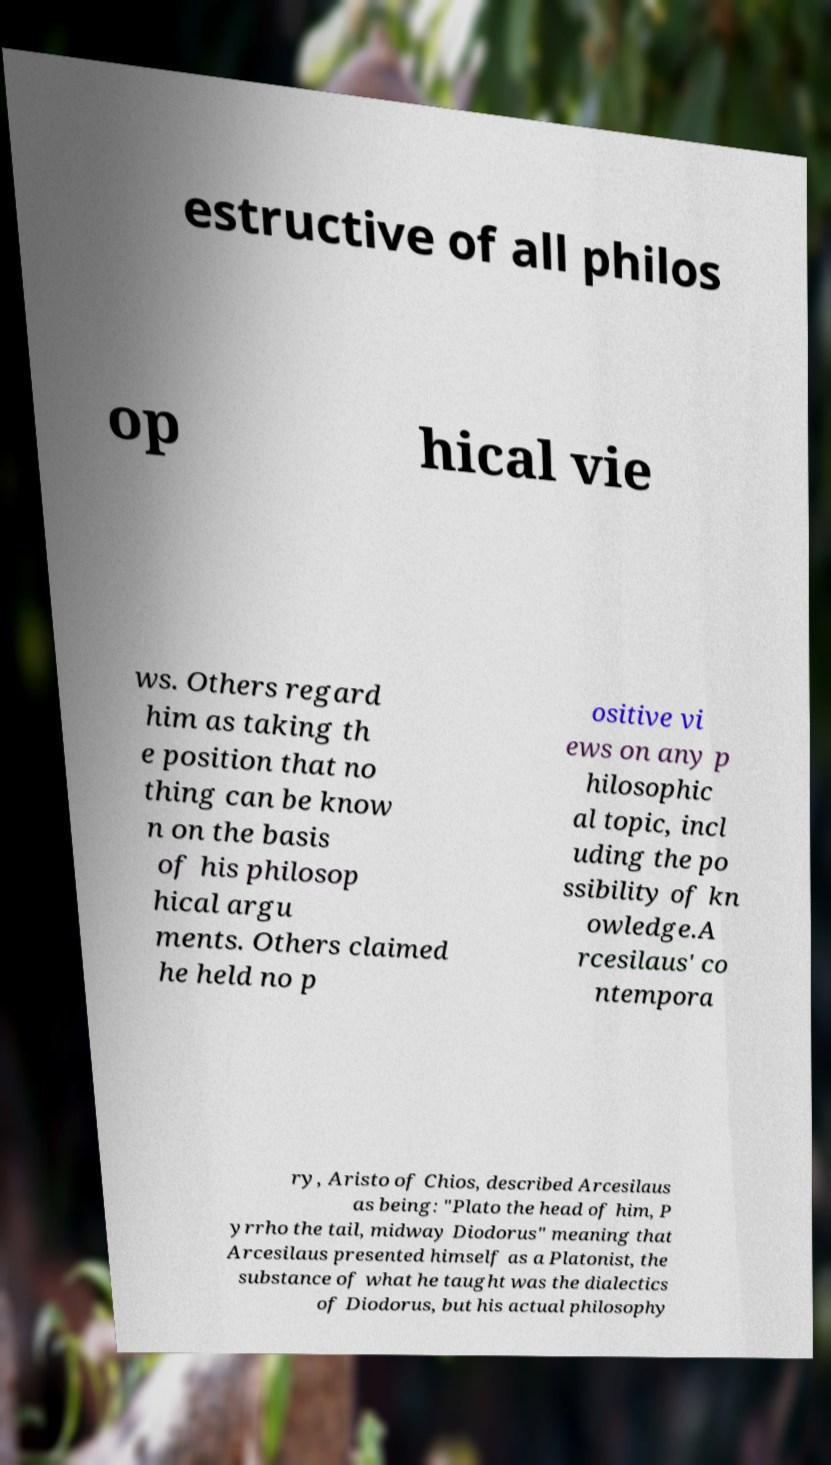Please identify and transcribe the text found in this image. estructive of all philos op hical vie ws. Others regard him as taking th e position that no thing can be know n on the basis of his philosop hical argu ments. Others claimed he held no p ositive vi ews on any p hilosophic al topic, incl uding the po ssibility of kn owledge.A rcesilaus' co ntempora ry, Aristo of Chios, described Arcesilaus as being: "Plato the head of him, P yrrho the tail, midway Diodorus" meaning that Arcesilaus presented himself as a Platonist, the substance of what he taught was the dialectics of Diodorus, but his actual philosophy 